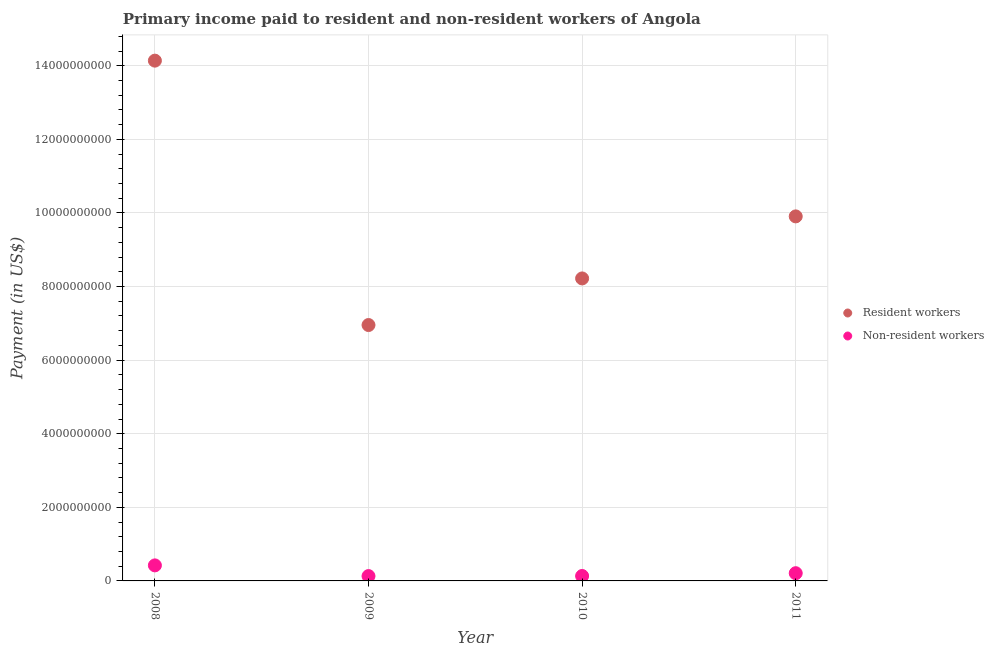Is the number of dotlines equal to the number of legend labels?
Make the answer very short. Yes. What is the payment made to resident workers in 2008?
Offer a terse response. 1.41e+1. Across all years, what is the maximum payment made to resident workers?
Your answer should be very brief. 1.41e+1. Across all years, what is the minimum payment made to non-resident workers?
Provide a short and direct response. 1.31e+08. In which year was the payment made to non-resident workers maximum?
Make the answer very short. 2008. In which year was the payment made to non-resident workers minimum?
Give a very brief answer. 2009. What is the total payment made to non-resident workers in the graph?
Offer a very short reply. 8.97e+08. What is the difference between the payment made to resident workers in 2010 and that in 2011?
Give a very brief answer. -1.69e+09. What is the difference between the payment made to non-resident workers in 2010 and the payment made to resident workers in 2009?
Offer a terse response. -6.82e+09. What is the average payment made to non-resident workers per year?
Give a very brief answer. 2.24e+08. In the year 2009, what is the difference between the payment made to non-resident workers and payment made to resident workers?
Make the answer very short. -6.82e+09. What is the ratio of the payment made to non-resident workers in 2008 to that in 2009?
Your answer should be compact. 3.22. Is the payment made to resident workers in 2008 less than that in 2009?
Your response must be concise. No. Is the difference between the payment made to resident workers in 2008 and 2011 greater than the difference between the payment made to non-resident workers in 2008 and 2011?
Provide a short and direct response. Yes. What is the difference between the highest and the second highest payment made to resident workers?
Offer a terse response. 4.23e+09. What is the difference between the highest and the lowest payment made to resident workers?
Make the answer very short. 7.19e+09. In how many years, is the payment made to non-resident workers greater than the average payment made to non-resident workers taken over all years?
Provide a short and direct response. 1. Is the sum of the payment made to non-resident workers in 2008 and 2011 greater than the maximum payment made to resident workers across all years?
Make the answer very short. No. How many dotlines are there?
Your response must be concise. 2. What is the difference between two consecutive major ticks on the Y-axis?
Give a very brief answer. 2.00e+09. Does the graph contain any zero values?
Provide a succinct answer. No. What is the title of the graph?
Keep it short and to the point. Primary income paid to resident and non-resident workers of Angola. What is the label or title of the Y-axis?
Your answer should be compact. Payment (in US$). What is the Payment (in US$) in Resident workers in 2008?
Provide a short and direct response. 1.41e+1. What is the Payment (in US$) of Non-resident workers in 2008?
Offer a very short reply. 4.22e+08. What is the Payment (in US$) in Resident workers in 2009?
Your response must be concise. 6.95e+09. What is the Payment (in US$) in Non-resident workers in 2009?
Give a very brief answer. 1.31e+08. What is the Payment (in US$) of Resident workers in 2010?
Make the answer very short. 8.22e+09. What is the Payment (in US$) of Non-resident workers in 2010?
Provide a succinct answer. 1.34e+08. What is the Payment (in US$) in Resident workers in 2011?
Make the answer very short. 9.91e+09. What is the Payment (in US$) in Non-resident workers in 2011?
Give a very brief answer. 2.10e+08. Across all years, what is the maximum Payment (in US$) in Resident workers?
Ensure brevity in your answer.  1.41e+1. Across all years, what is the maximum Payment (in US$) in Non-resident workers?
Your answer should be compact. 4.22e+08. Across all years, what is the minimum Payment (in US$) of Resident workers?
Your response must be concise. 6.95e+09. Across all years, what is the minimum Payment (in US$) in Non-resident workers?
Your answer should be very brief. 1.31e+08. What is the total Payment (in US$) of Resident workers in the graph?
Keep it short and to the point. 3.92e+1. What is the total Payment (in US$) in Non-resident workers in the graph?
Your response must be concise. 8.97e+08. What is the difference between the Payment (in US$) in Resident workers in 2008 and that in 2009?
Ensure brevity in your answer.  7.19e+09. What is the difference between the Payment (in US$) of Non-resident workers in 2008 and that in 2009?
Your response must be concise. 2.91e+08. What is the difference between the Payment (in US$) of Resident workers in 2008 and that in 2010?
Offer a very short reply. 5.92e+09. What is the difference between the Payment (in US$) of Non-resident workers in 2008 and that in 2010?
Offer a very short reply. 2.88e+08. What is the difference between the Payment (in US$) of Resident workers in 2008 and that in 2011?
Make the answer very short. 4.23e+09. What is the difference between the Payment (in US$) in Non-resident workers in 2008 and that in 2011?
Offer a very short reply. 2.12e+08. What is the difference between the Payment (in US$) of Resident workers in 2009 and that in 2010?
Give a very brief answer. -1.27e+09. What is the difference between the Payment (in US$) of Non-resident workers in 2009 and that in 2010?
Provide a succinct answer. -2.70e+06. What is the difference between the Payment (in US$) in Resident workers in 2009 and that in 2011?
Ensure brevity in your answer.  -2.95e+09. What is the difference between the Payment (in US$) in Non-resident workers in 2009 and that in 2011?
Offer a terse response. -7.85e+07. What is the difference between the Payment (in US$) in Resident workers in 2010 and that in 2011?
Your answer should be compact. -1.69e+09. What is the difference between the Payment (in US$) in Non-resident workers in 2010 and that in 2011?
Offer a very short reply. -7.58e+07. What is the difference between the Payment (in US$) of Resident workers in 2008 and the Payment (in US$) of Non-resident workers in 2009?
Ensure brevity in your answer.  1.40e+1. What is the difference between the Payment (in US$) of Resident workers in 2008 and the Payment (in US$) of Non-resident workers in 2010?
Provide a short and direct response. 1.40e+1. What is the difference between the Payment (in US$) in Resident workers in 2008 and the Payment (in US$) in Non-resident workers in 2011?
Provide a short and direct response. 1.39e+1. What is the difference between the Payment (in US$) of Resident workers in 2009 and the Payment (in US$) of Non-resident workers in 2010?
Your answer should be very brief. 6.82e+09. What is the difference between the Payment (in US$) of Resident workers in 2009 and the Payment (in US$) of Non-resident workers in 2011?
Your answer should be compact. 6.74e+09. What is the difference between the Payment (in US$) of Resident workers in 2010 and the Payment (in US$) of Non-resident workers in 2011?
Your response must be concise. 8.01e+09. What is the average Payment (in US$) in Resident workers per year?
Offer a terse response. 9.81e+09. What is the average Payment (in US$) of Non-resident workers per year?
Offer a terse response. 2.24e+08. In the year 2008, what is the difference between the Payment (in US$) in Resident workers and Payment (in US$) in Non-resident workers?
Provide a short and direct response. 1.37e+1. In the year 2009, what is the difference between the Payment (in US$) in Resident workers and Payment (in US$) in Non-resident workers?
Your response must be concise. 6.82e+09. In the year 2010, what is the difference between the Payment (in US$) of Resident workers and Payment (in US$) of Non-resident workers?
Your response must be concise. 8.09e+09. In the year 2011, what is the difference between the Payment (in US$) of Resident workers and Payment (in US$) of Non-resident workers?
Provide a succinct answer. 9.70e+09. What is the ratio of the Payment (in US$) of Resident workers in 2008 to that in 2009?
Offer a terse response. 2.03. What is the ratio of the Payment (in US$) in Non-resident workers in 2008 to that in 2009?
Offer a terse response. 3.22. What is the ratio of the Payment (in US$) in Resident workers in 2008 to that in 2010?
Your response must be concise. 1.72. What is the ratio of the Payment (in US$) in Non-resident workers in 2008 to that in 2010?
Make the answer very short. 3.15. What is the ratio of the Payment (in US$) of Resident workers in 2008 to that in 2011?
Provide a succinct answer. 1.43. What is the ratio of the Payment (in US$) of Non-resident workers in 2008 to that in 2011?
Give a very brief answer. 2.01. What is the ratio of the Payment (in US$) in Resident workers in 2009 to that in 2010?
Make the answer very short. 0.85. What is the ratio of the Payment (in US$) of Non-resident workers in 2009 to that in 2010?
Your response must be concise. 0.98. What is the ratio of the Payment (in US$) in Resident workers in 2009 to that in 2011?
Keep it short and to the point. 0.7. What is the ratio of the Payment (in US$) in Non-resident workers in 2009 to that in 2011?
Give a very brief answer. 0.63. What is the ratio of the Payment (in US$) of Resident workers in 2010 to that in 2011?
Make the answer very short. 0.83. What is the ratio of the Payment (in US$) of Non-resident workers in 2010 to that in 2011?
Provide a short and direct response. 0.64. What is the difference between the highest and the second highest Payment (in US$) of Resident workers?
Provide a short and direct response. 4.23e+09. What is the difference between the highest and the second highest Payment (in US$) of Non-resident workers?
Provide a succinct answer. 2.12e+08. What is the difference between the highest and the lowest Payment (in US$) in Resident workers?
Your response must be concise. 7.19e+09. What is the difference between the highest and the lowest Payment (in US$) of Non-resident workers?
Provide a short and direct response. 2.91e+08. 